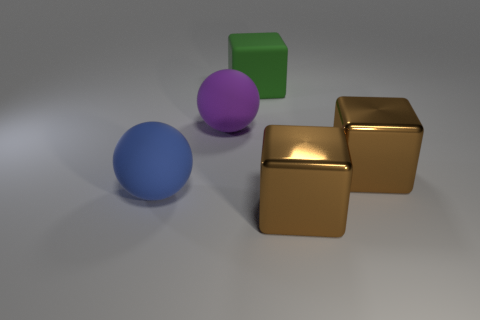Is the purple object the same size as the blue rubber object?
Your response must be concise. Yes. What number of objects are large brown shiny blocks to the right of the big green matte cube or rubber blocks?
Make the answer very short. 3. There is a brown object that is to the right of the large brown block in front of the blue sphere; what is its shape?
Your answer should be very brief. Cube. There is a purple matte object; is it the same size as the rubber object that is in front of the purple object?
Keep it short and to the point. Yes. What is the thing that is in front of the blue ball made of?
Your response must be concise. Metal. What number of objects are both in front of the large green rubber cube and to the right of the big blue matte object?
Provide a short and direct response. 3. There is a blue sphere that is the same size as the green object; what is it made of?
Your answer should be compact. Rubber. There is a object in front of the large blue thing; is it the same size as the matte ball in front of the big purple rubber thing?
Make the answer very short. Yes. There is a green cube; are there any large metallic cubes behind it?
Your answer should be compact. No. What is the color of the large metallic object in front of the large metal block behind the big blue matte sphere?
Provide a succinct answer. Brown. 